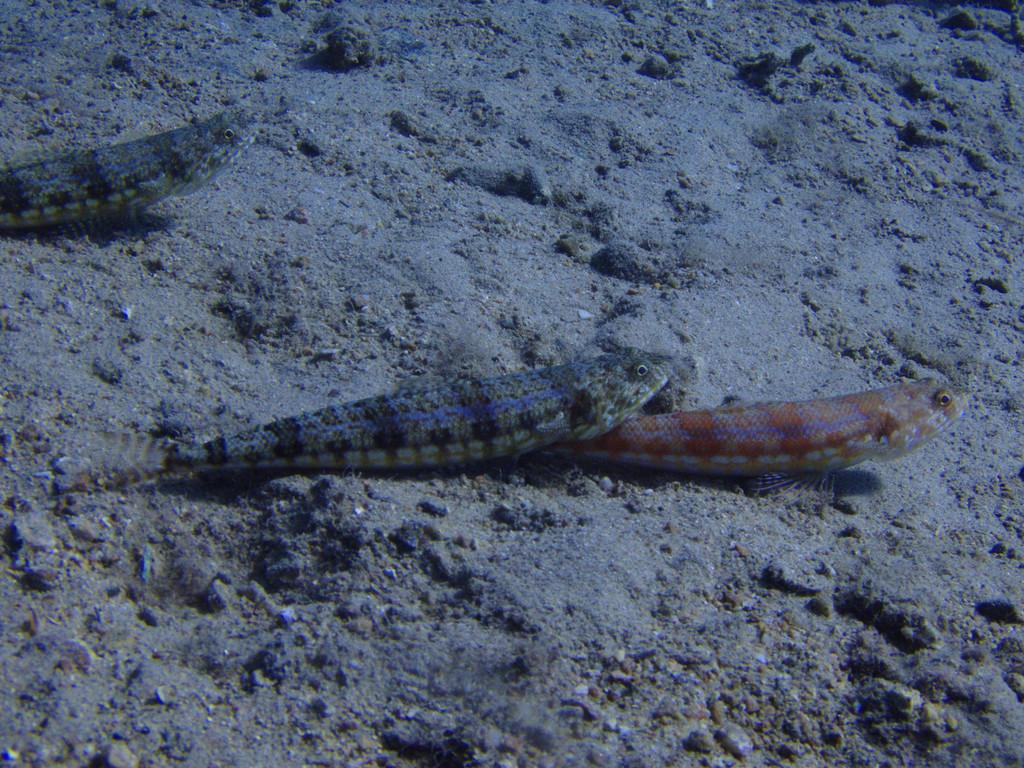How many fishes can be seen in the image? There are three fishes in the image. What else is present in the image besides the fishes? There are stones in the image. Can you describe the setting of the image? The image appears to be taken in or near water. What type of punishment is being given to the fishes in the image? There is no punishment being given to the fishes in the image; they are simply swimming near the stones. 